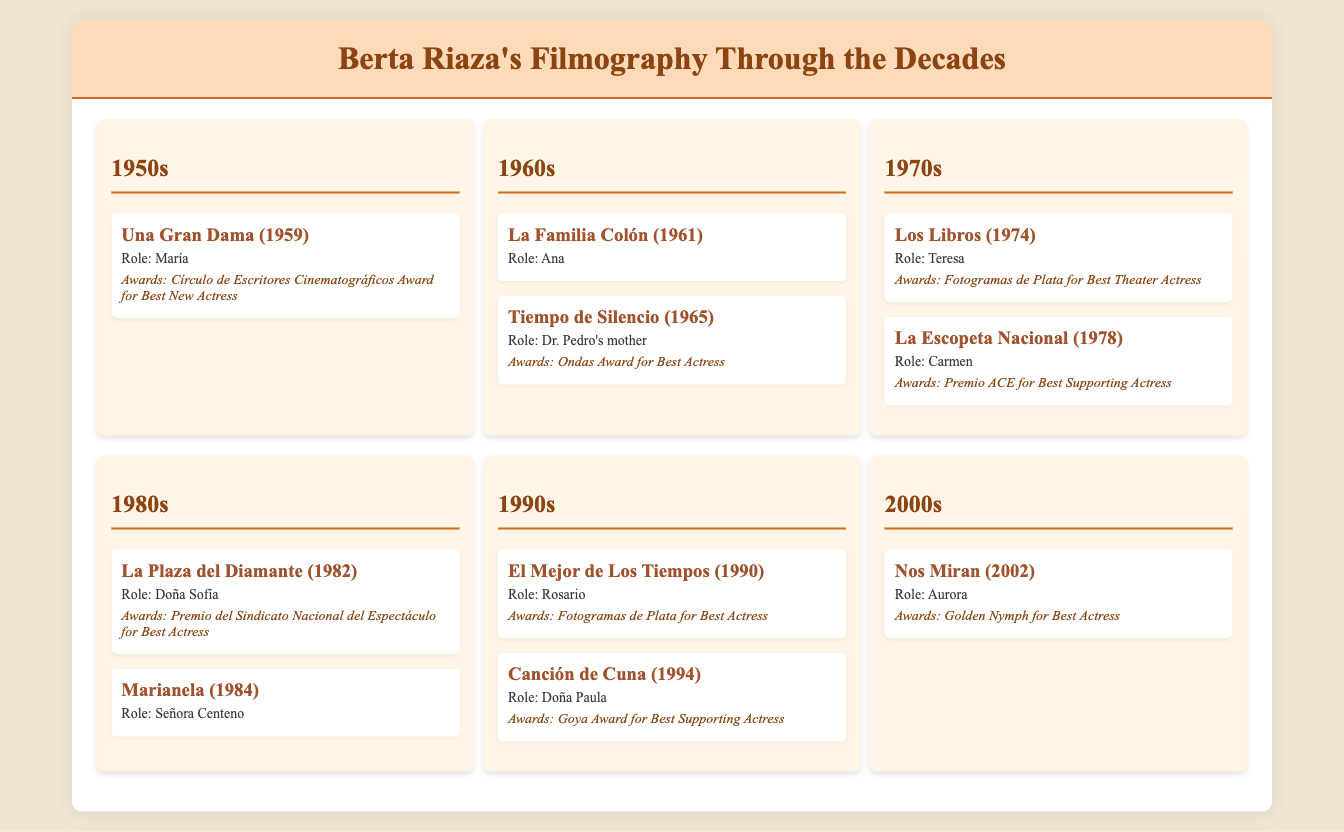what was Berta Riaza's first notable performance? The first notable performance listed in the document is "Una Gran Dama" from 1959.
Answer: Una Gran Dama (1959) which award did she win for "Tiempo de Silencio"? The award won for "Tiempo de Silencio" is the Ondas Award for Best Actress.
Answer: Ondas Award for Best Actress how many performances are mentioned for the 1980s? There are two performances mentioned for the 1980s: "La Plaza del Diamante" and "Marianela."
Answer: 2 in which decade did she receive the Golden Nymph for Best Actress? The Golden Nymph for Best Actress was awarded for the performance in "Nos Miran," which is in the 2000s.
Answer: 2000s what role did Berta Riaza play in "La Escopeta Nacional"? In "La Escopeta Nacional," she played the role of Carmen.
Answer: Carmen which performance earned her the Goya Award for Best Supporting Actress? The performance that earned her the Goya Award for Best Supporting Actress is "Canción de Cuna."
Answer: Canción de Cuna 